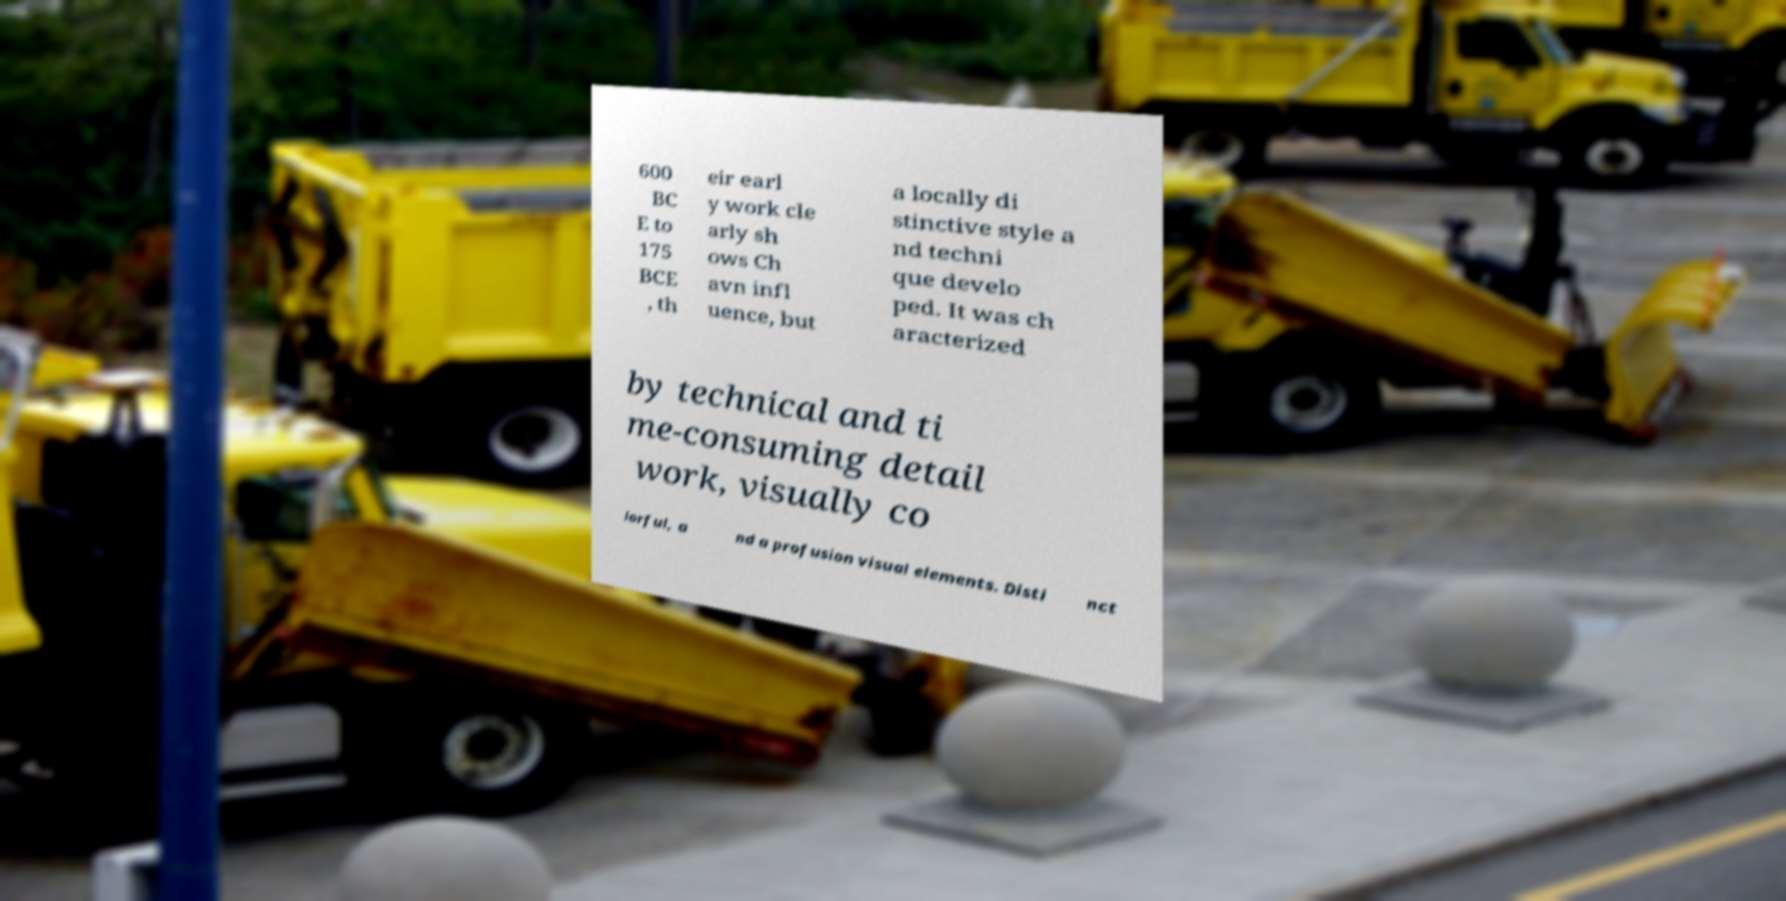Please read and relay the text visible in this image. What does it say? 600 BC E to 175 BCE , th eir earl y work cle arly sh ows Ch avn infl uence, but a locally di stinctive style a nd techni que develo ped. It was ch aracterized by technical and ti me-consuming detail work, visually co lorful, a nd a profusion visual elements. Disti nct 